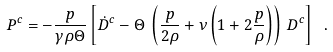<formula> <loc_0><loc_0><loc_500><loc_500>P ^ { c } = - \frac { p } { \gamma \rho \Theta } \left [ \dot { D } ^ { c } - \Theta \, \left ( \frac { p } { 2 \rho } + \nu \left ( 1 + 2 \frac { p } { \rho } \right ) \right ) \, D ^ { c } \right ] \ .</formula> 